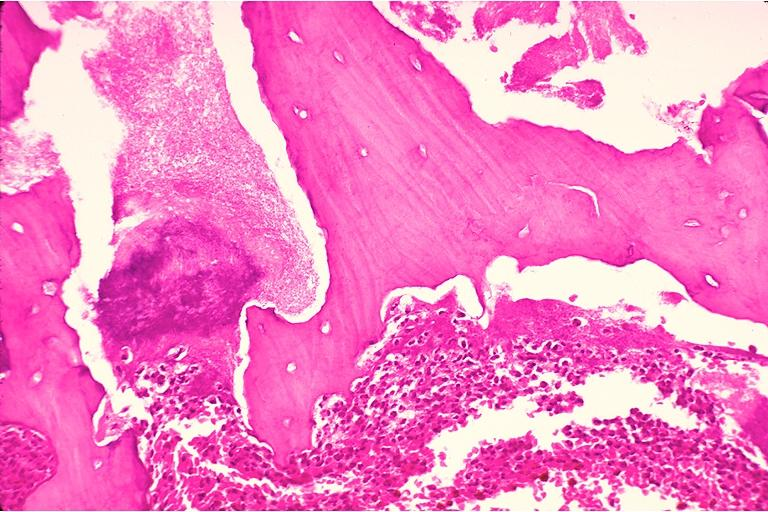does cut edge of mesentery show chronic osteomyelitis?
Answer the question using a single word or phrase. No 